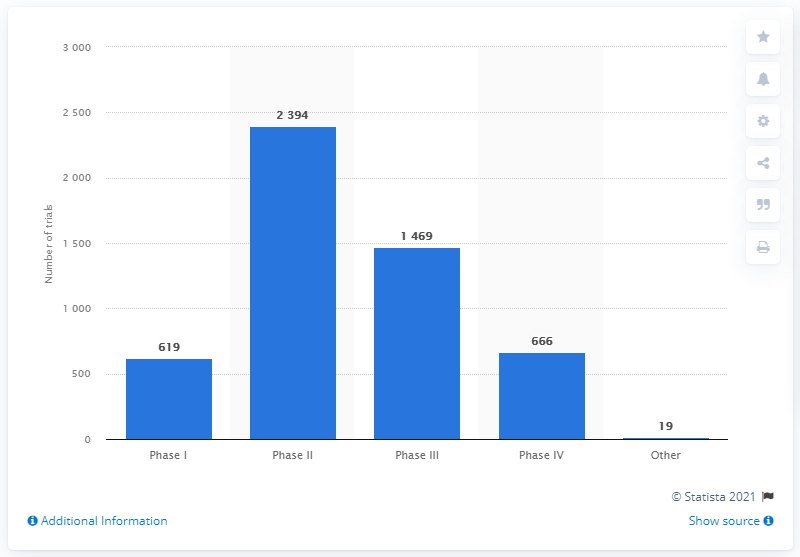Specify some key components in this picture. There were 619 trials still in the first phase. Six hundred sixty-six trials had already been conducted in phase IV at the time of the incident. 